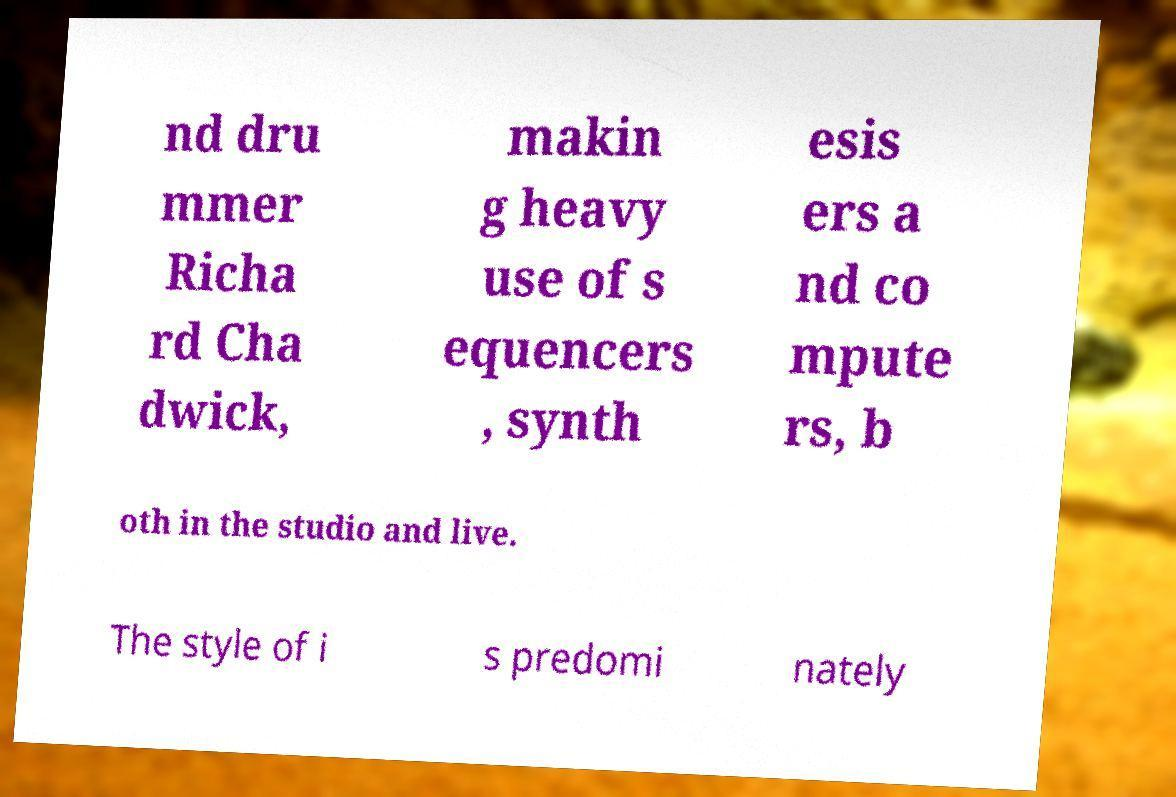There's text embedded in this image that I need extracted. Can you transcribe it verbatim? nd dru mmer Richa rd Cha dwick, makin g heavy use of s equencers , synth esis ers a nd co mpute rs, b oth in the studio and live. The style of i s predomi nately 